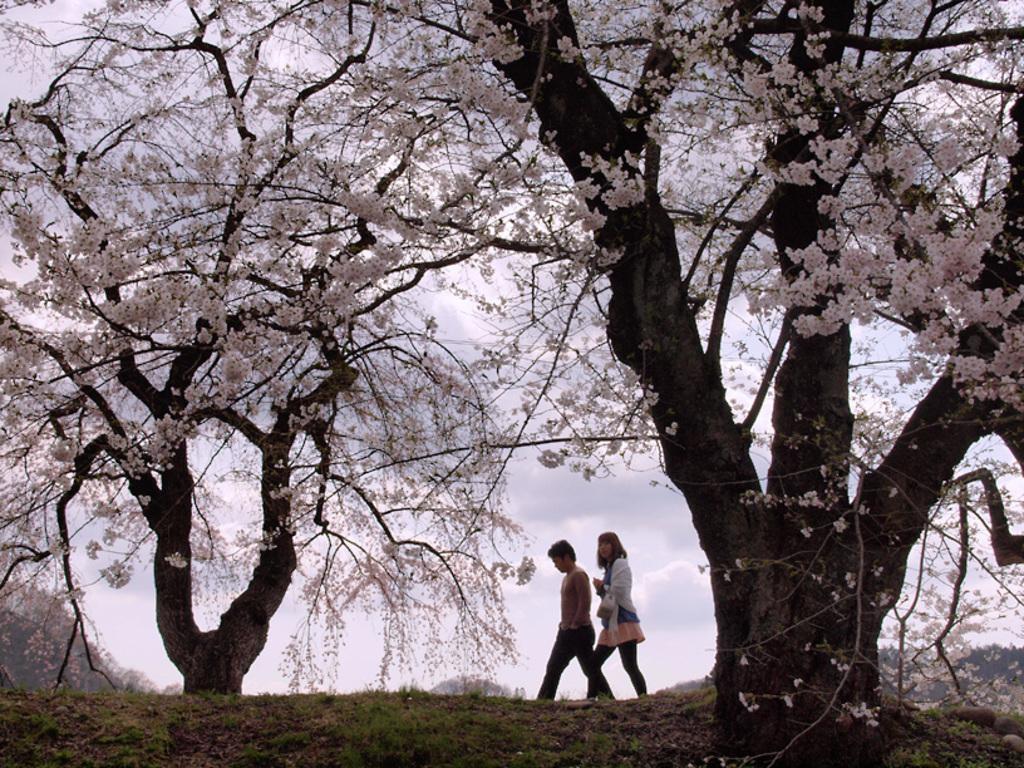How would you summarize this image in a sentence or two? In this image I can see two persons walking. The person in front wearing white shirt, black pant. Background I can see dried trees, white color flowers and sky is in white color. 